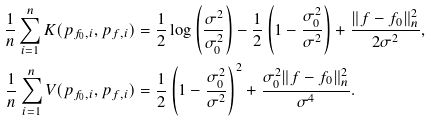<formula> <loc_0><loc_0><loc_500><loc_500>\frac { 1 } { n } \sum _ { i = 1 } ^ { n } K ( p _ { f _ { 0 } , i } , p _ { f , i } ) & = \frac { 1 } { 2 } \log { \left ( \frac { \sigma ^ { 2 } } { \sigma _ { 0 } ^ { 2 } } \right ) } - \frac { 1 } { 2 } \left ( 1 - \frac { \sigma _ { 0 } ^ { 2 } } { \sigma ^ { 2 } } \right ) + \frac { \| f - f _ { 0 } \| _ { n } ^ { 2 } } { 2 \sigma ^ { 2 } } , \\ \frac { 1 } { n } \sum _ { i = 1 } ^ { n } V ( p _ { f _ { 0 } , i } , p _ { f , i } ) & = \frac { 1 } { 2 } \left ( 1 - \frac { \sigma _ { 0 } ^ { 2 } } { \sigma ^ { 2 } } \right ) ^ { 2 } + \frac { \sigma _ { 0 } ^ { 2 } \| f - f _ { 0 } \| _ { n } ^ { 2 } } { \sigma ^ { 4 } } .</formula> 